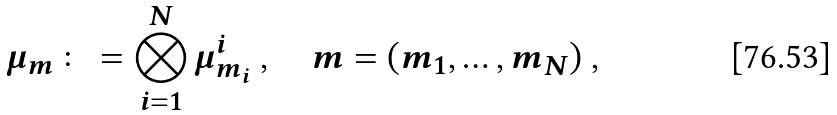<formula> <loc_0><loc_0><loc_500><loc_500>\mu _ { m } \colon = \bigotimes _ { i = 1 } ^ { N } \mu _ { m _ { i } } ^ { i } \ , \quad m = ( m _ { 1 } , \dots , m _ { N } ) \ ,</formula> 